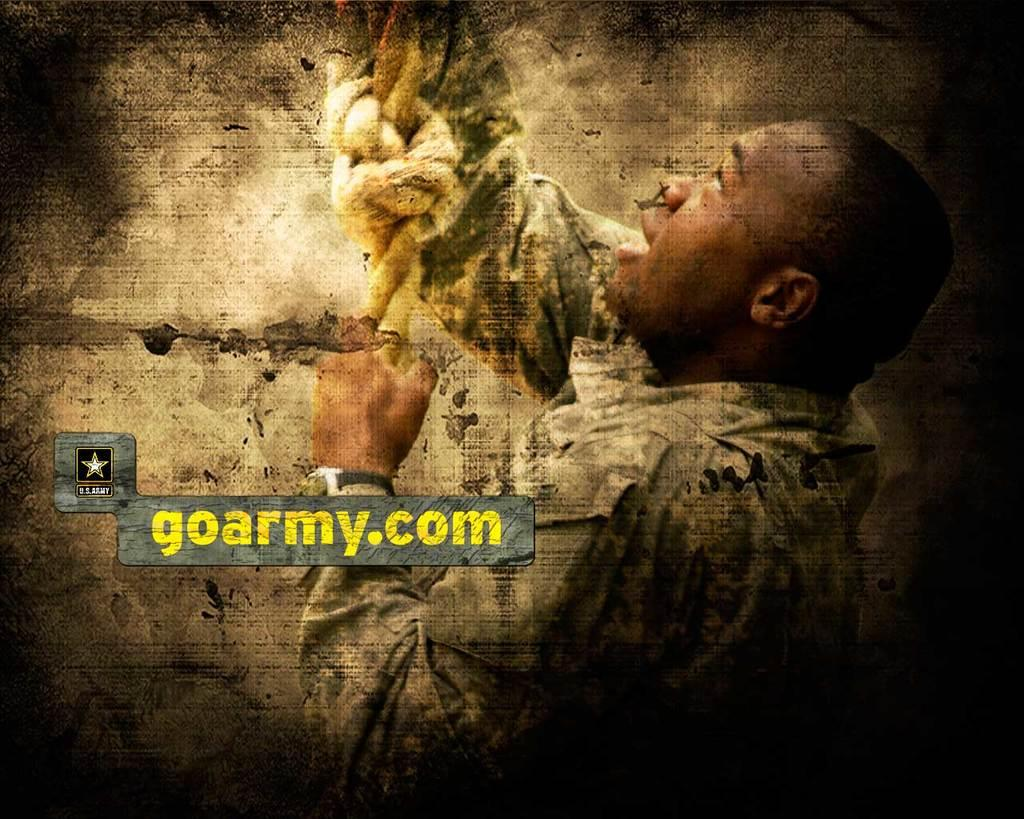What is the main subject of the image? There is a person in the image. What is the person holding in the image? The person is holding a rope. Can you describe any additional features of the image? There is a watermark on the image. What shape is the surprise that the person is holding in the image? There is no surprise present in the image, and therefore no shape can be determined. 